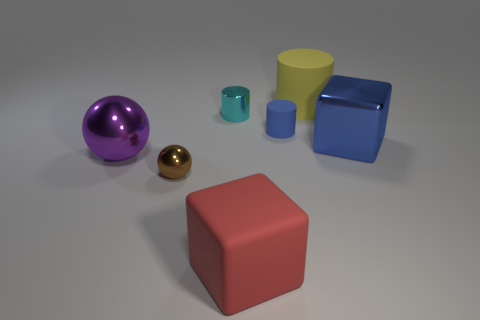What might be the purpose of these objects being placed together? Given their varied shapes and colors, these objects could be used to demonstrate different geometric forms and color theory, perhaps for an educational purpose or a visual exercise in 3D modeling and rendering. What do the different shapes represent? Each shape likely represents a fundamental geometric form: the spheres show round, three-dimensional objects; the cubes represent six-sided, equally proportioned objects; the cylinder illustrates a circular base extended in one dimension, and the cone shows a circular base tapering smoothly to a point. 